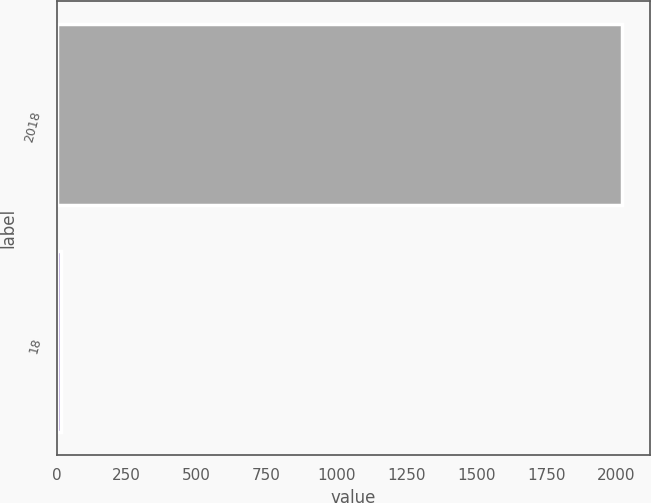<chart> <loc_0><loc_0><loc_500><loc_500><bar_chart><fcel>2018<fcel>18<nl><fcel>2020<fcel>17<nl></chart> 